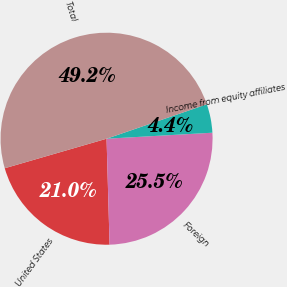Convert chart. <chart><loc_0><loc_0><loc_500><loc_500><pie_chart><fcel>United States<fcel>Foreign<fcel>Income from equity affiliates<fcel>Total<nl><fcel>20.96%<fcel>25.45%<fcel>4.36%<fcel>49.23%<nl></chart> 